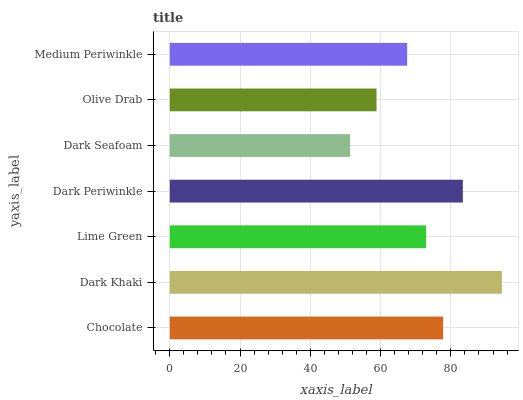Is Dark Seafoam the minimum?
Answer yes or no. Yes. Is Dark Khaki the maximum?
Answer yes or no. Yes. Is Lime Green the minimum?
Answer yes or no. No. Is Lime Green the maximum?
Answer yes or no. No. Is Dark Khaki greater than Lime Green?
Answer yes or no. Yes. Is Lime Green less than Dark Khaki?
Answer yes or no. Yes. Is Lime Green greater than Dark Khaki?
Answer yes or no. No. Is Dark Khaki less than Lime Green?
Answer yes or no. No. Is Lime Green the high median?
Answer yes or no. Yes. Is Lime Green the low median?
Answer yes or no. Yes. Is Chocolate the high median?
Answer yes or no. No. Is Dark Khaki the low median?
Answer yes or no. No. 